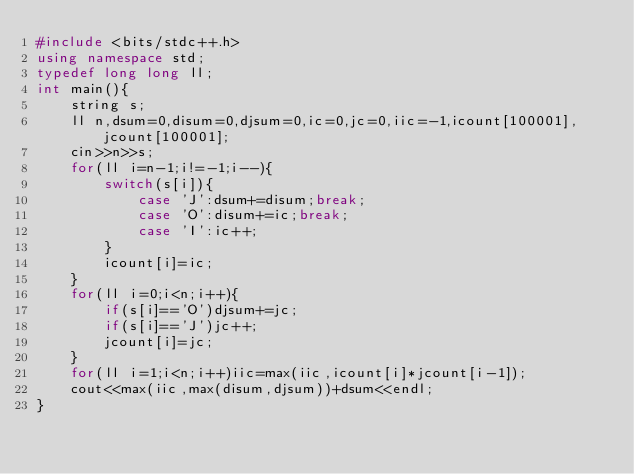Convert code to text. <code><loc_0><loc_0><loc_500><loc_500><_C++_>#include <bits/stdc++.h>
using namespace std;
typedef long long ll;
int main(){
	string s;
	ll n,dsum=0,disum=0,djsum=0,ic=0,jc=0,iic=-1,icount[100001],jcount[100001];
	cin>>n>>s;
	for(ll i=n-1;i!=-1;i--){
		switch(s[i]){
			case 'J':dsum+=disum;break;
			case 'O':disum+=ic;break;
			case 'I':ic++;
		}
		icount[i]=ic;
	}
	for(ll i=0;i<n;i++){
		if(s[i]=='O')djsum+=jc;
		if(s[i]=='J')jc++;
		jcount[i]=jc;
	}
	for(ll i=1;i<n;i++)iic=max(iic,icount[i]*jcount[i-1]);
	cout<<max(iic,max(disum,djsum))+dsum<<endl;
}</code> 